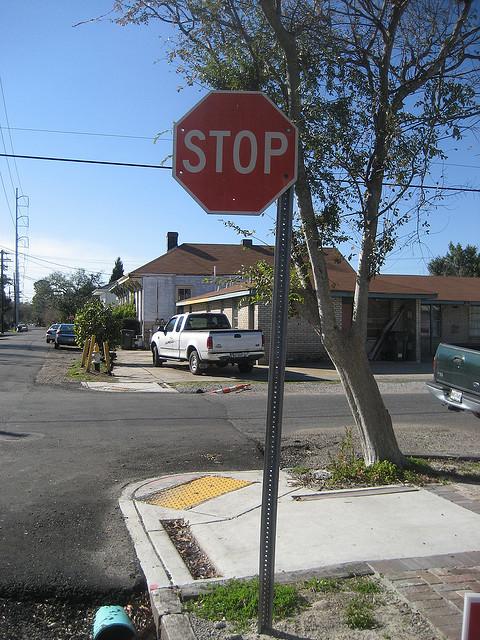What type of car is shown?
Write a very short answer. Truck. How many flags are on the building?
Concise answer only. 0. Is this normally how stop signs are hung?
Concise answer only. No. What color is the wheelchair ramp on the sidewalk corner?
Give a very brief answer. Yellow. How many street signs are in the photo?
Be succinct. 1. 